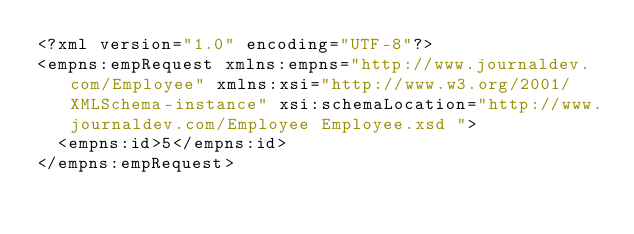<code> <loc_0><loc_0><loc_500><loc_500><_XML_><?xml version="1.0" encoding="UTF-8"?>
<empns:empRequest xmlns:empns="http://www.journaldev.com/Employee" xmlns:xsi="http://www.w3.org/2001/XMLSchema-instance" xsi:schemaLocation="http://www.journaldev.com/Employee Employee.xsd ">
  <empns:id>5</empns:id>
</empns:empRequest>
</code> 